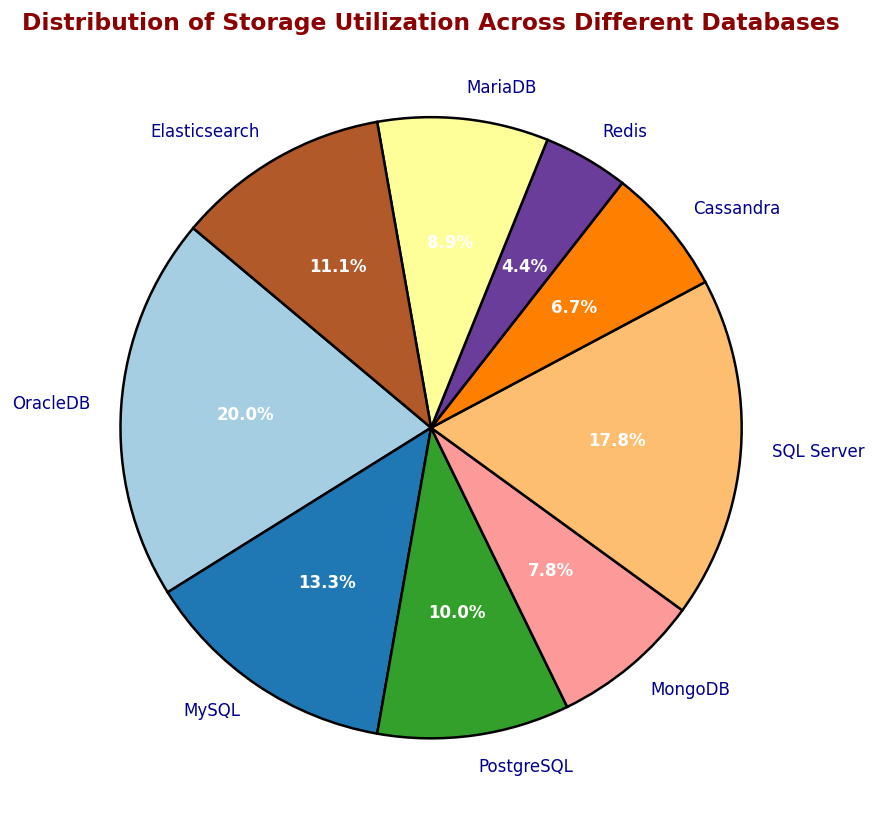Which database has the highest storage utilization? The pie chart shows different databases with their corresponding percentages of storage utilization. The largest wedge represents OracleDB.
Answer: OracleDB Which two databases combined have the same storage utilization as OracleDB, approximately? From the figure, we see OracleDB consumes 450 GB. MySQL and SQL Server together sum up to approximately this value (300 GB + 400 GB = 700 GB slightly more)
Answer: MySQL and SQL Server What's the average storage utilization across all listed databases? Sum all the storage utilization and divide by the number of databases: (450 + 300 + 225 + 175 + 400 + 150 + 100 + 200 + 250) GB / 9 databases = 2,250 GB / 9 = 250 GB.
Answer: 250 GB Which database has the least storage utilization? The pie chart shows the smallest percentage of storage for Redis.
Answer: Redis What is the combined storage utilization of PostgreSQL, Cassandra, and MariaDB? Add up the storage utilization of PostgreSQL (225 GB), Cassandra (150 GB), and MariaDB (200 GB): 225 + 150 + 200 = 575 GB.
Answer: 575 GB 